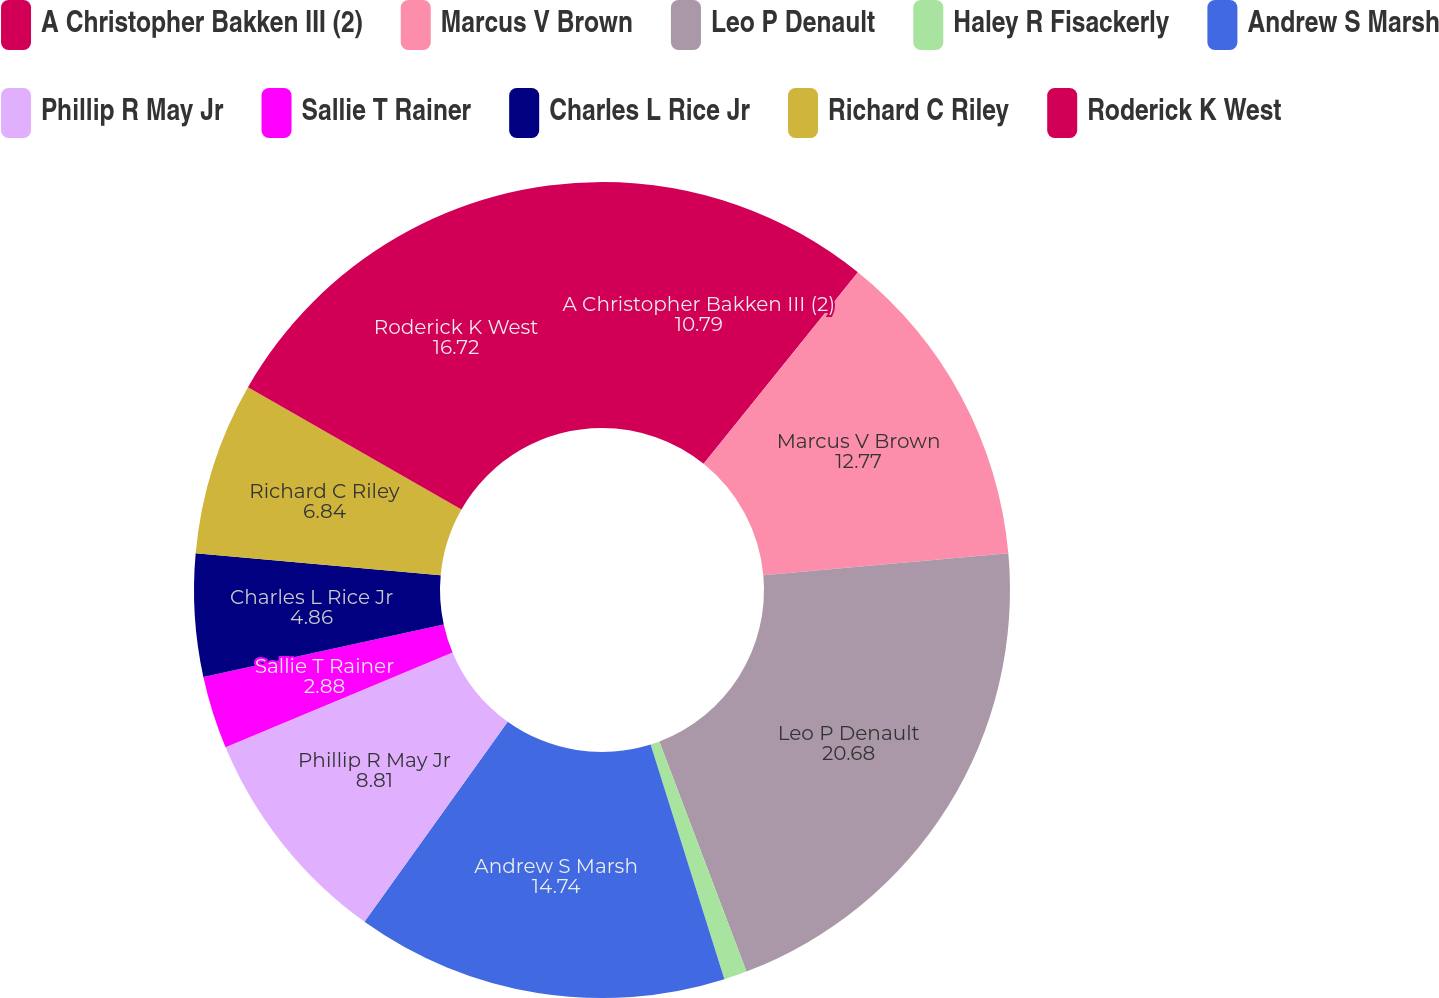<chart> <loc_0><loc_0><loc_500><loc_500><pie_chart><fcel>A Christopher Bakken III (2)<fcel>Marcus V Brown<fcel>Leo P Denault<fcel>Haley R Fisackerly<fcel>Andrew S Marsh<fcel>Phillip R May Jr<fcel>Sallie T Rainer<fcel>Charles L Rice Jr<fcel>Richard C Riley<fcel>Roderick K West<nl><fcel>10.79%<fcel>12.77%<fcel>20.68%<fcel>0.91%<fcel>14.74%<fcel>8.81%<fcel>2.88%<fcel>4.86%<fcel>6.84%<fcel>16.72%<nl></chart> 